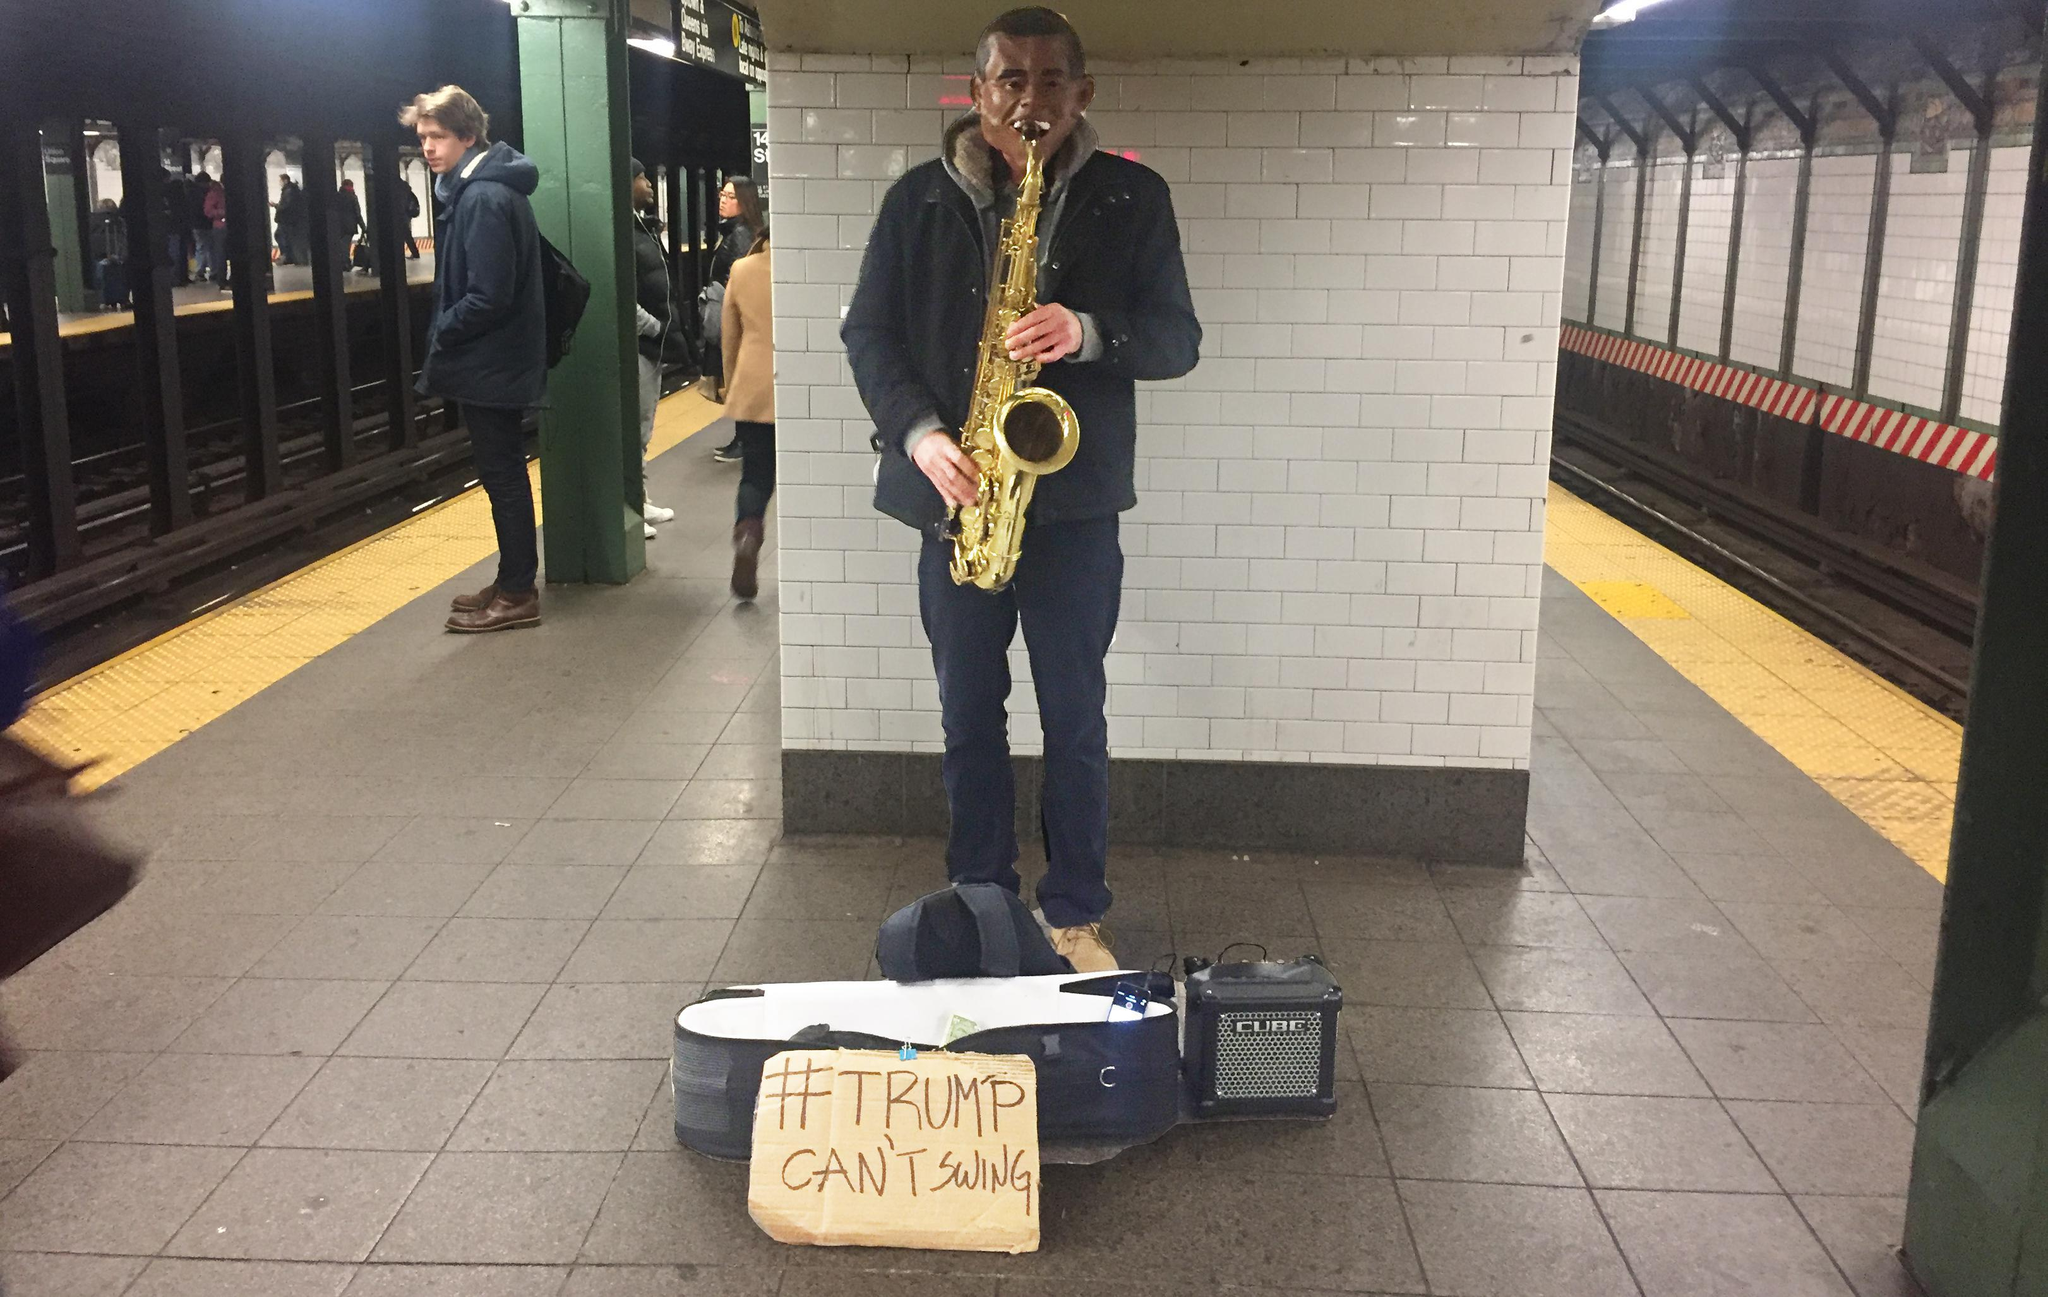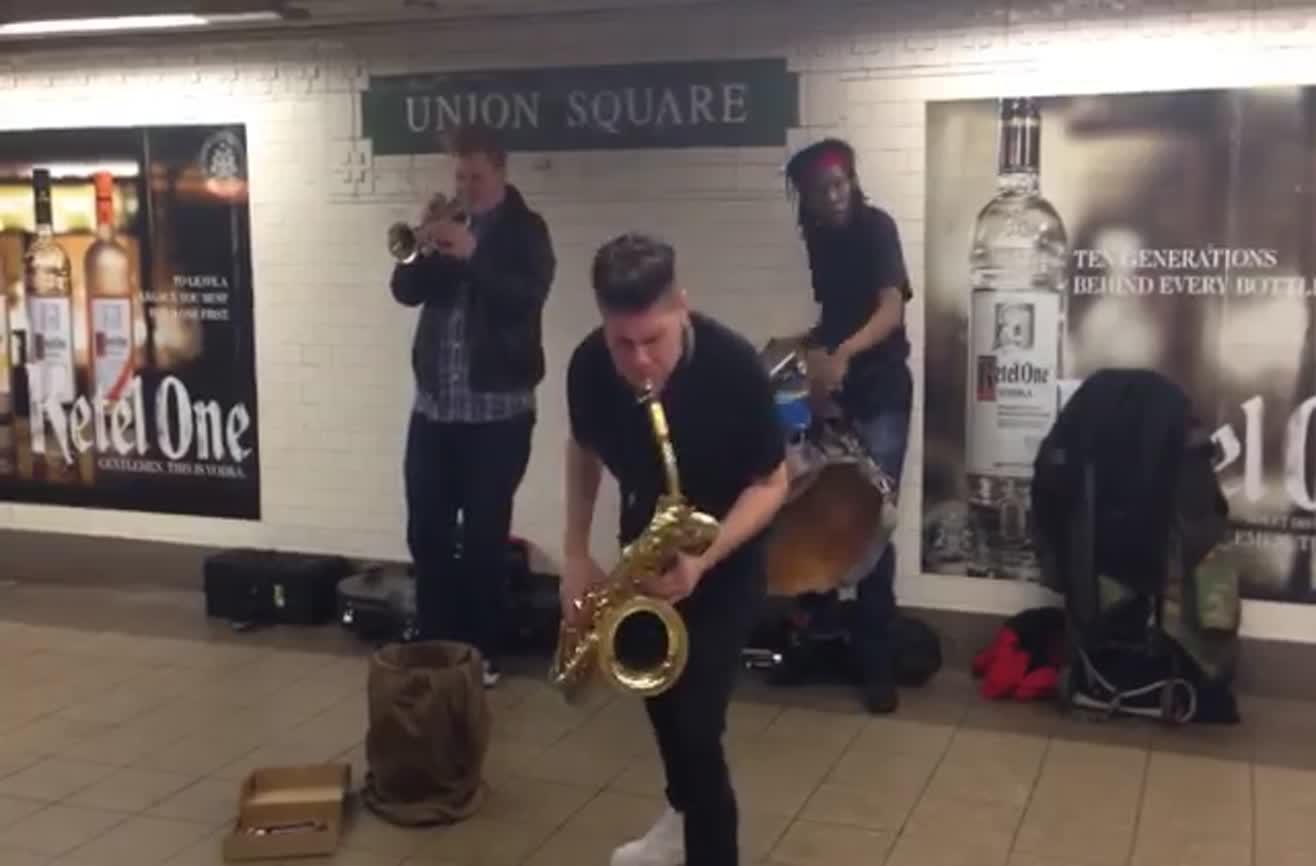The first image is the image on the left, the second image is the image on the right. Assess this claim about the two images: "The right image includes a sax player, drummer and horn player standing in a station with images of liquor bottles behind them and a bucket-type container on the floor by them.". Correct or not? Answer yes or no. Yes. The first image is the image on the left, the second image is the image on the right. Evaluate the accuracy of this statement regarding the images: "There are three men playing instrument in the subway with two of them where rlong black pants.". Is it true? Answer yes or no. Yes. 